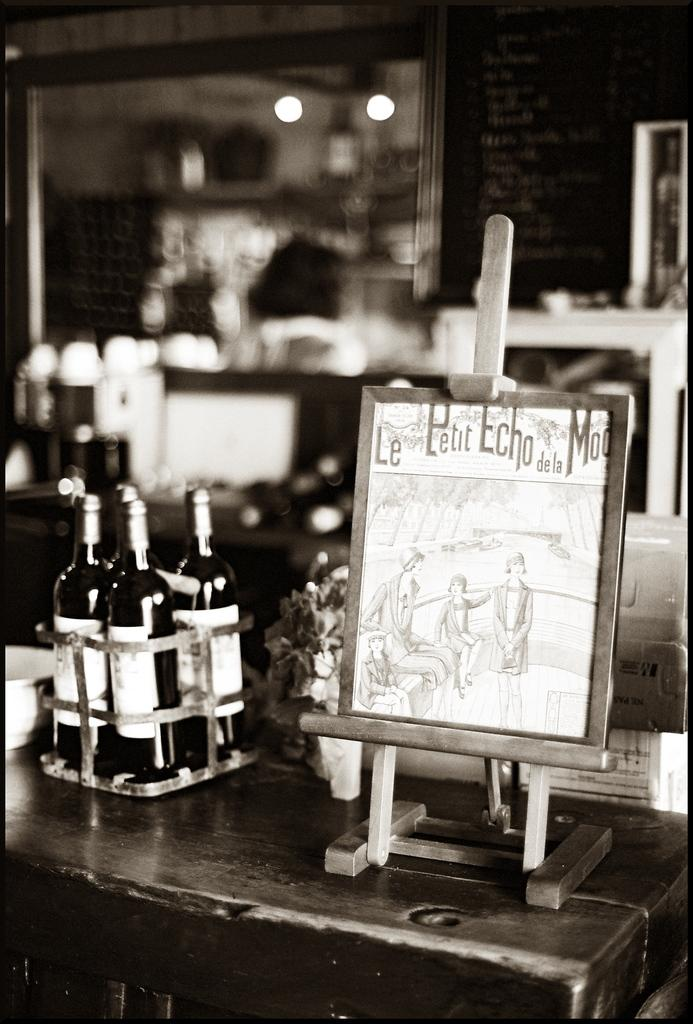What is the main subject of the image? There is a sketch in a frame in the image. Can you describe any other objects in the image? Yes, there are bottles visible in the image. How many ants are crawling on the sketch in the image? There are no ants present in the image; it only features a sketch in a frame and bottles. 